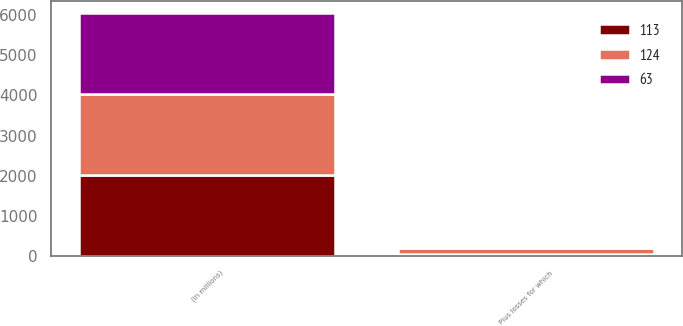<chart> <loc_0><loc_0><loc_500><loc_500><stacked_bar_chart><ecel><fcel>(In millions)<fcel>Plus losses for which<nl><fcel>63<fcel>2012<fcel>28<nl><fcel>113<fcel>2011<fcel>55<nl><fcel>124<fcel>2010<fcel>142<nl></chart> 